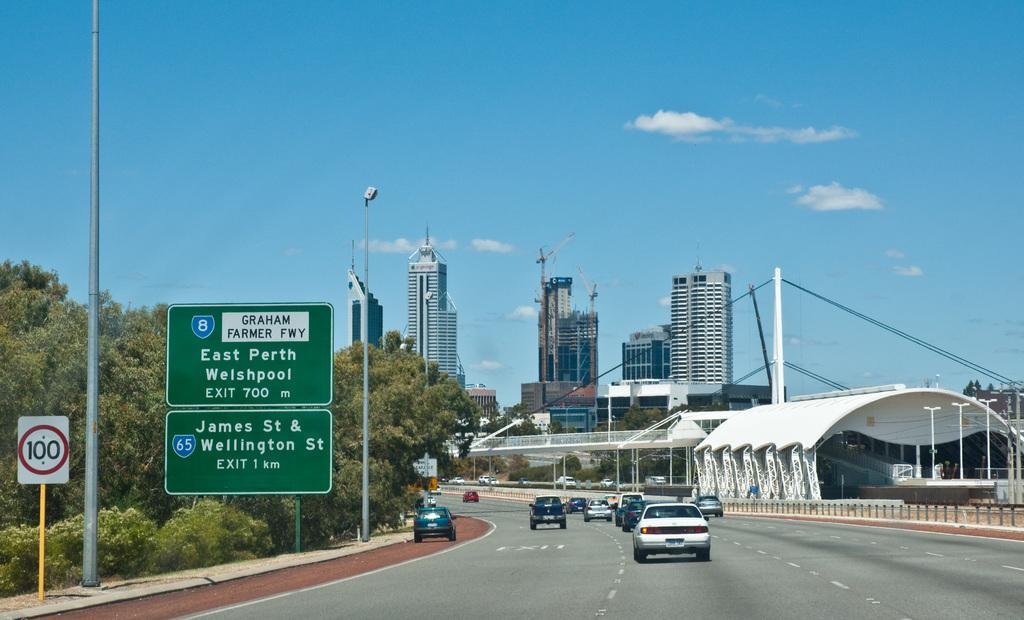<image>
Relay a brief, clear account of the picture shown. Cars are traveling on a freeway in Europe and next exit is East Porth Welshpool. 